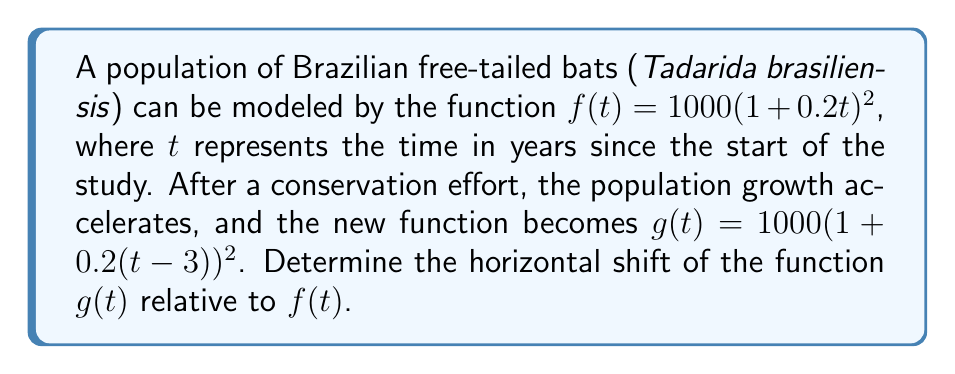Can you answer this question? To determine the horizontal shift, we need to compare the general forms of $f(t)$ and $g(t)$.

1) The general form of a horizontally shifted function is:
   $g(t) = f(t - h)$, where $h$ is the horizontal shift.

2) In our case:
   $f(t) = 1000(1+0.2t)^2$
   $g(t) = 1000(1+0.2(t-3))^2$

3) Comparing $g(t)$ to the general form:
   $g(t) = 1000(1+0.2(t-3))^2 = f(t-3)$

4) This means that to get from $t$ to $(t-3)$, we're subtracting 3 from $t$.

5) Therefore, the graph of $g(t)$ is shifted 3 units to the right compared to $f(t)$.

6) In the context of the bat population, this means the accelerated growth pattern starts 3 years after the beginning of the original study.
Answer: 3 units right 